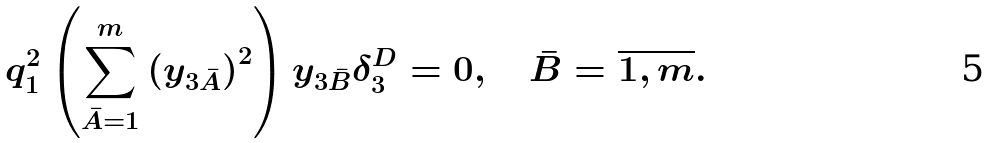Convert formula to latex. <formula><loc_0><loc_0><loc_500><loc_500>q _ { 1 } ^ { 2 } \left ( \sum _ { \bar { A } = 1 } ^ { m } \left ( y _ { 3 \bar { A } } \right ) ^ { 2 } \right ) y _ { 3 \bar { B } } \delta _ { 3 } ^ { D } = 0 , \quad \bar { B } = \overline { 1 , m } .</formula> 